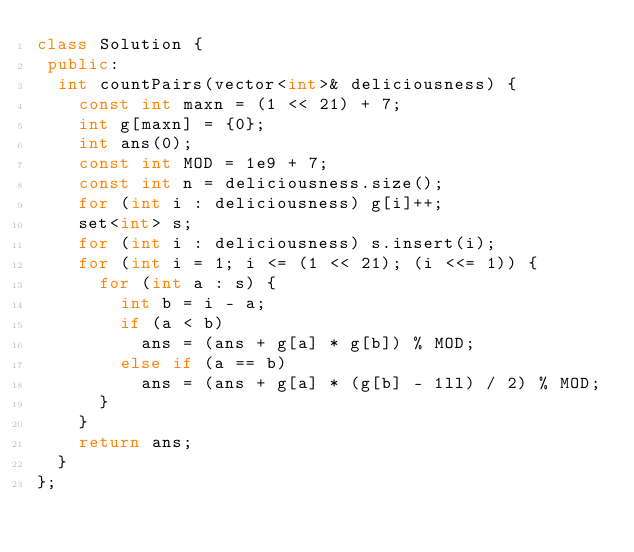<code> <loc_0><loc_0><loc_500><loc_500><_C++_>class Solution {
 public:
  int countPairs(vector<int>& deliciousness) {
    const int maxn = (1 << 21) + 7;
    int g[maxn] = {0};
    int ans(0);
    const int MOD = 1e9 + 7;
    const int n = deliciousness.size();
    for (int i : deliciousness) g[i]++;
    set<int> s;
    for (int i : deliciousness) s.insert(i);
    for (int i = 1; i <= (1 << 21); (i <<= 1)) {
      for (int a : s) {
        int b = i - a;
        if (a < b)
          ans = (ans + g[a] * g[b]) % MOD;
        else if (a == b)
          ans = (ans + g[a] * (g[b] - 1ll) / 2) % MOD;
      }
    }
    return ans;
  }
};</code> 